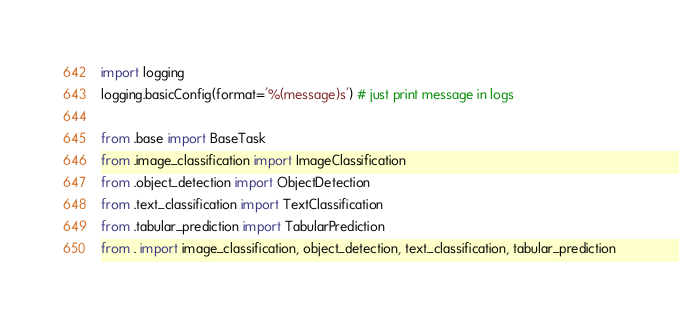Convert code to text. <code><loc_0><loc_0><loc_500><loc_500><_Python_>import logging
logging.basicConfig(format='%(message)s') # just print message in logs

from .base import BaseTask
from .image_classification import ImageClassification
from .object_detection import ObjectDetection
from .text_classification import TextClassification
from .tabular_prediction import TabularPrediction
from . import image_classification, object_detection, text_classification, tabular_prediction
</code> 